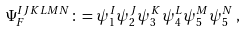Convert formula to latex. <formula><loc_0><loc_0><loc_500><loc_500>\Psi _ { F } ^ { I J K L M N } \colon = \psi _ { 1 } ^ { I } \psi _ { 2 } ^ { J } \psi _ { 3 } ^ { K } \psi _ { 4 } ^ { L } \psi _ { 5 } ^ { M } \psi _ { 5 } ^ { N } \, ,</formula> 